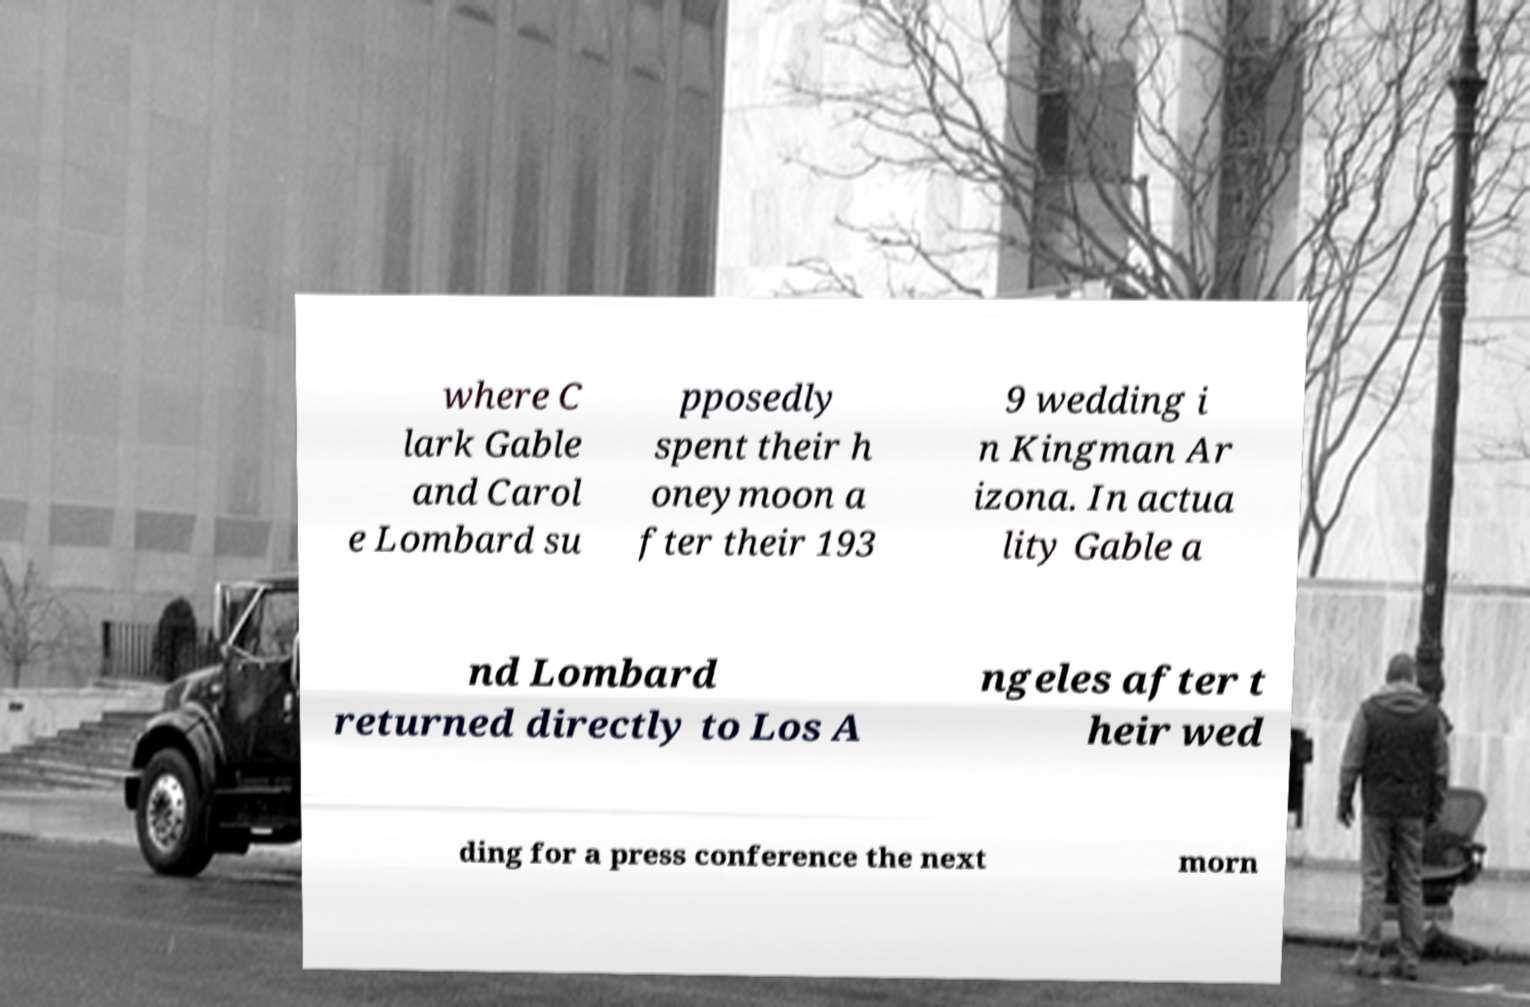Please read and relay the text visible in this image. What does it say? where C lark Gable and Carol e Lombard su pposedly spent their h oneymoon a fter their 193 9 wedding i n Kingman Ar izona. In actua lity Gable a nd Lombard returned directly to Los A ngeles after t heir wed ding for a press conference the next morn 